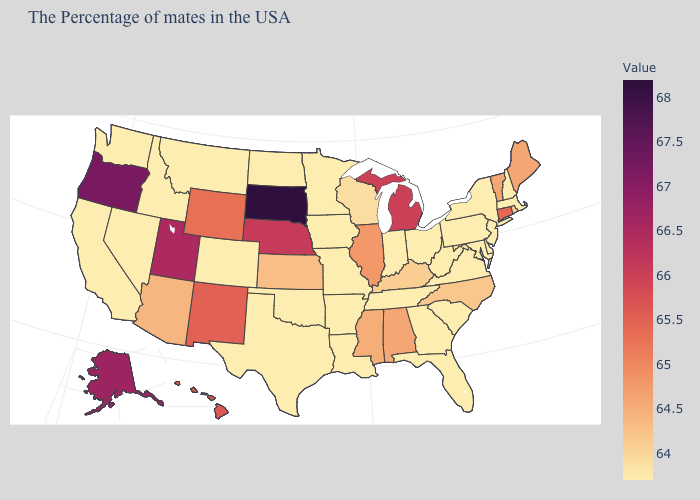Which states have the highest value in the USA?
Concise answer only. South Dakota. Is the legend a continuous bar?
Give a very brief answer. Yes. Which states have the lowest value in the USA?
Keep it brief. Massachusetts, New Hampshire, New York, New Jersey, Delaware, Maryland, Pennsylvania, Virginia, South Carolina, West Virginia, Ohio, Florida, Georgia, Indiana, Tennessee, Louisiana, Missouri, Arkansas, Minnesota, Iowa, Oklahoma, Texas, North Dakota, Colorado, Montana, Idaho, Nevada, California, Washington. Which states hav the highest value in the Northeast?
Answer briefly. Connecticut. Does the map have missing data?
Quick response, please. No. Among the states that border Missouri , does Iowa have the lowest value?
Give a very brief answer. Yes. Which states hav the highest value in the South?
Quick response, please. Alabama. Does Alaska have a higher value than Arkansas?
Write a very short answer. Yes. 